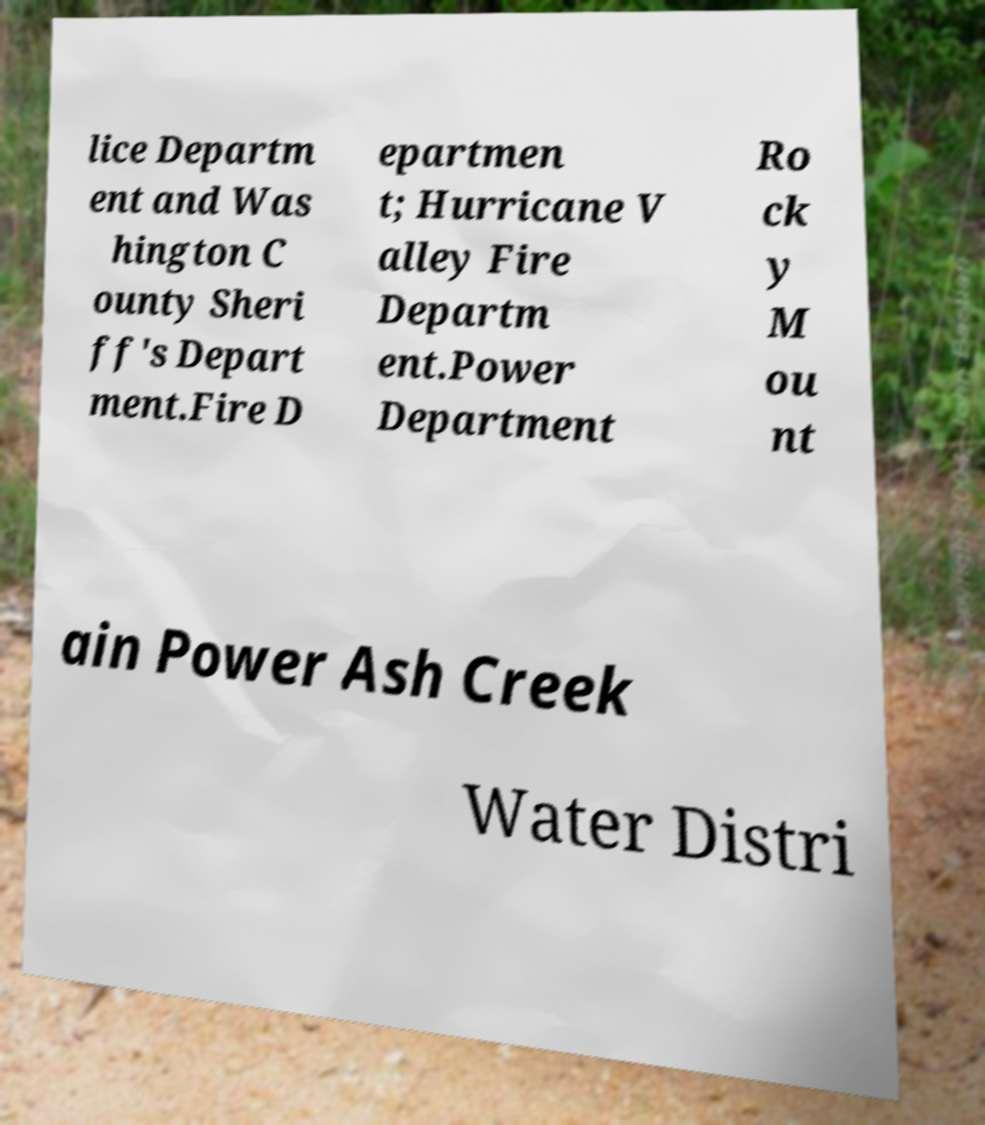Can you accurately transcribe the text from the provided image for me? lice Departm ent and Was hington C ounty Sheri ff's Depart ment.Fire D epartmen t; Hurricane V alley Fire Departm ent.Power Department Ro ck y M ou nt ain Power Ash Creek Water Distri 